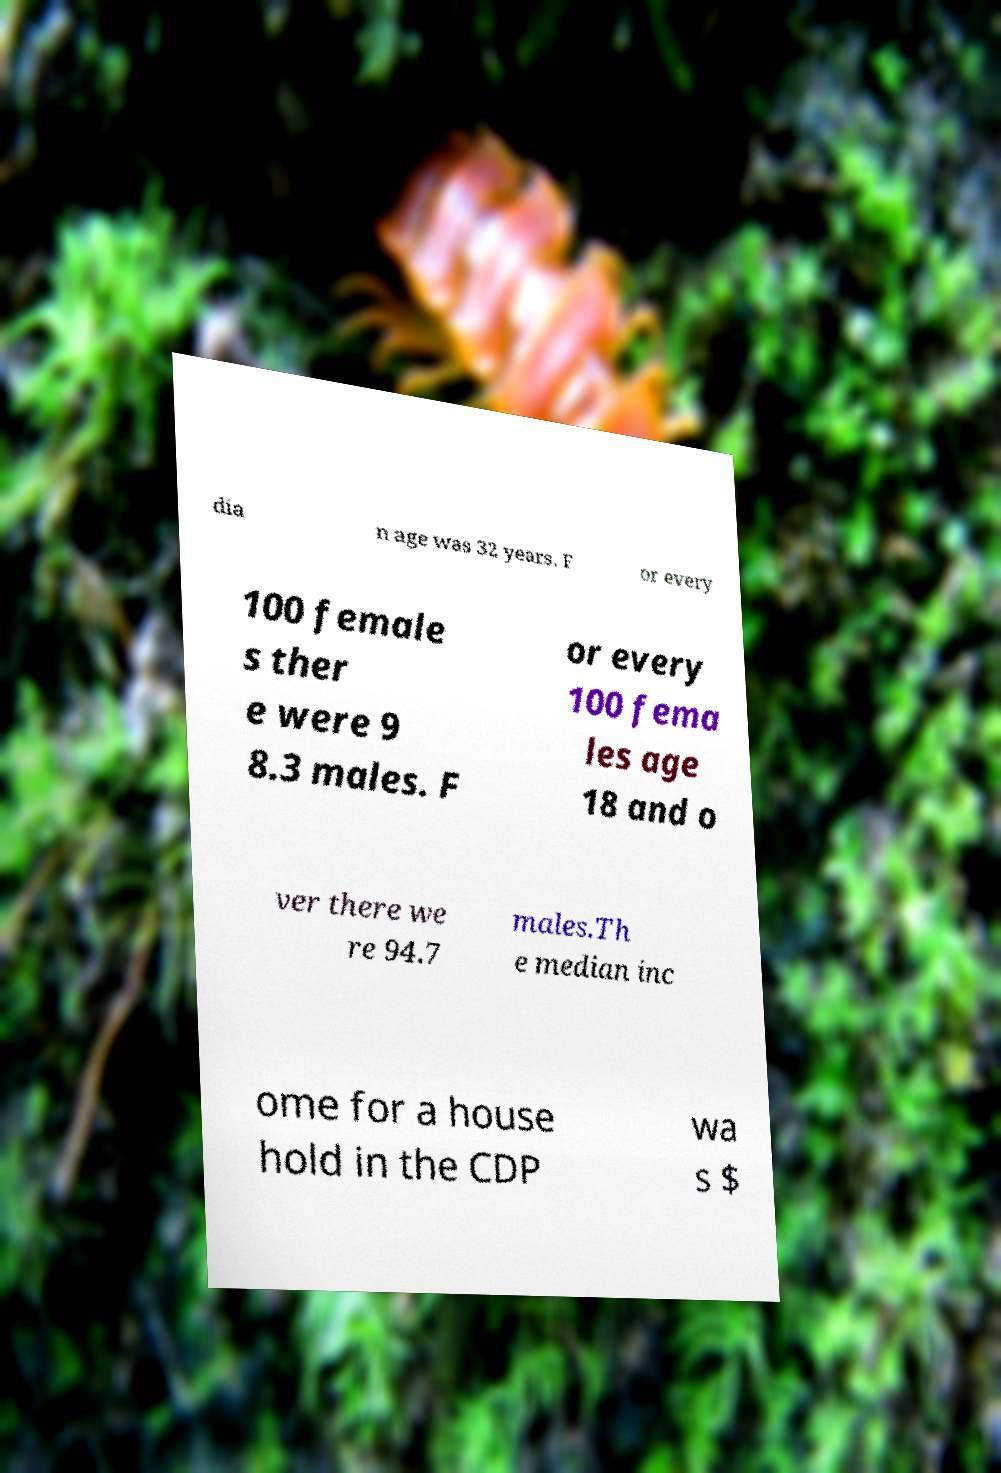Please read and relay the text visible in this image. What does it say? dia n age was 32 years. F or every 100 female s ther e were 9 8.3 males. F or every 100 fema les age 18 and o ver there we re 94.7 males.Th e median inc ome for a house hold in the CDP wa s $ 